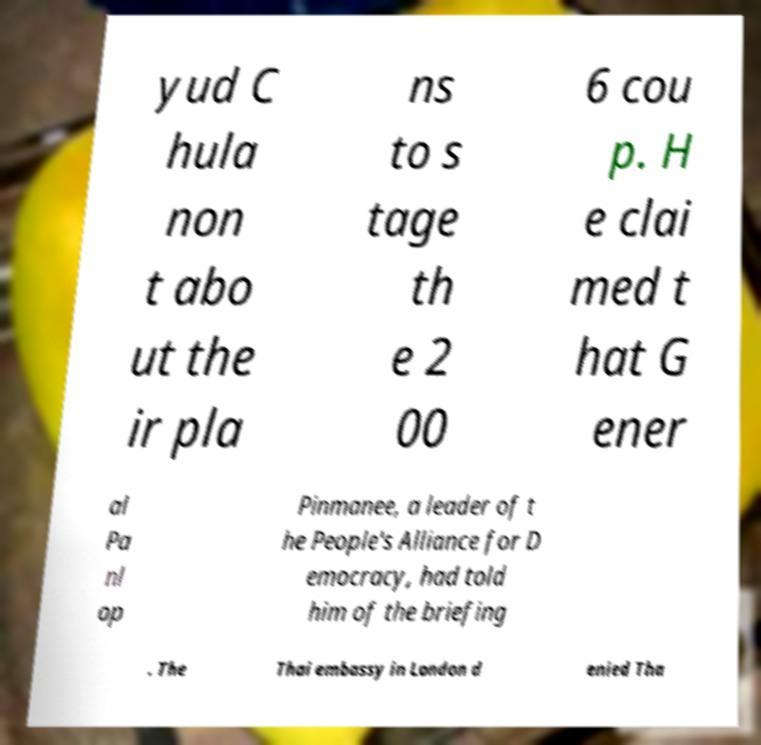Could you assist in decoding the text presented in this image and type it out clearly? yud C hula non t abo ut the ir pla ns to s tage th e 2 00 6 cou p. H e clai med t hat G ener al Pa nl op Pinmanee, a leader of t he People's Alliance for D emocracy, had told him of the briefing . The Thai embassy in London d enied Tha 